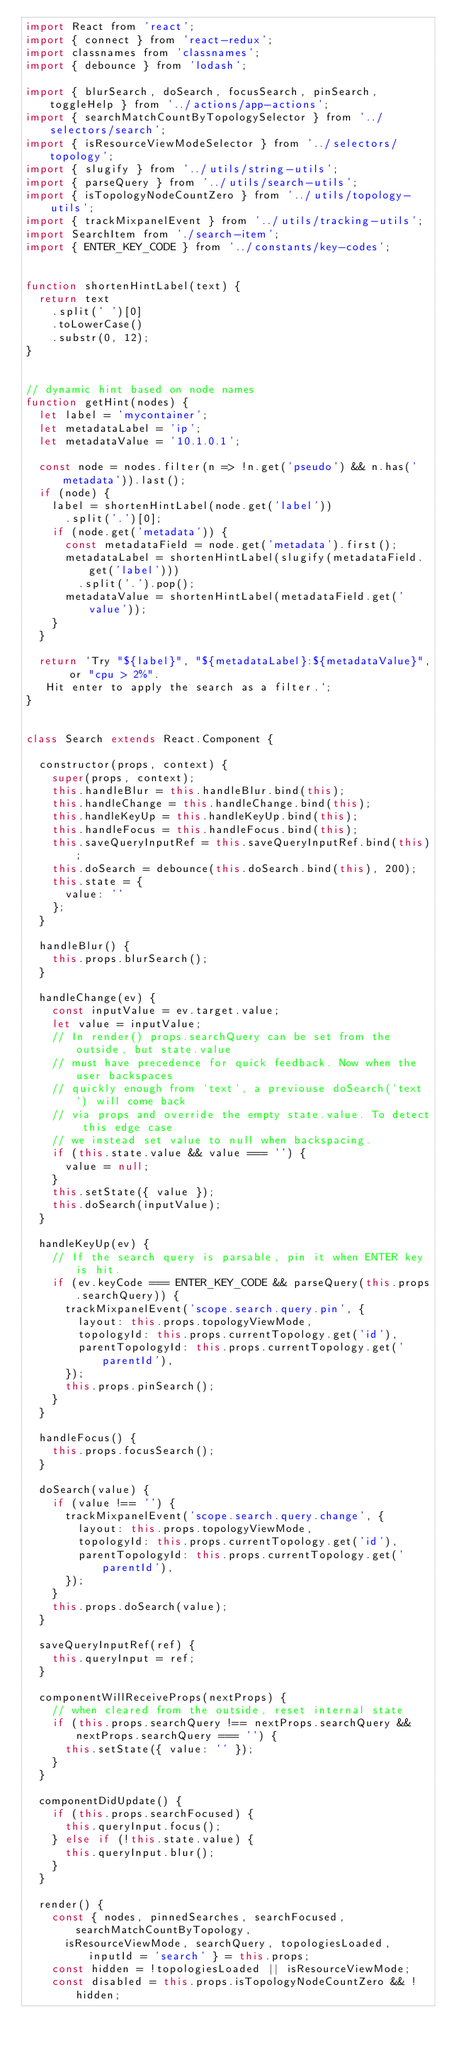Convert code to text. <code><loc_0><loc_0><loc_500><loc_500><_JavaScript_>import React from 'react';
import { connect } from 'react-redux';
import classnames from 'classnames';
import { debounce } from 'lodash';

import { blurSearch, doSearch, focusSearch, pinSearch, toggleHelp } from '../actions/app-actions';
import { searchMatchCountByTopologySelector } from '../selectors/search';
import { isResourceViewModeSelector } from '../selectors/topology';
import { slugify } from '../utils/string-utils';
import { parseQuery } from '../utils/search-utils';
import { isTopologyNodeCountZero } from '../utils/topology-utils';
import { trackMixpanelEvent } from '../utils/tracking-utils';
import SearchItem from './search-item';
import { ENTER_KEY_CODE } from '../constants/key-codes';


function shortenHintLabel(text) {
  return text
    .split(' ')[0]
    .toLowerCase()
    .substr(0, 12);
}


// dynamic hint based on node names
function getHint(nodes) {
  let label = 'mycontainer';
  let metadataLabel = 'ip';
  let metadataValue = '10.1.0.1';

  const node = nodes.filter(n => !n.get('pseudo') && n.has('metadata')).last();
  if (node) {
    label = shortenHintLabel(node.get('label'))
      .split('.')[0];
    if (node.get('metadata')) {
      const metadataField = node.get('metadata').first();
      metadataLabel = shortenHintLabel(slugify(metadataField.get('label')))
        .split('.').pop();
      metadataValue = shortenHintLabel(metadataField.get('value'));
    }
  }

  return `Try "${label}", "${metadataLabel}:${metadataValue}", or "cpu > 2%".
   Hit enter to apply the search as a filter.`;
}


class Search extends React.Component {

  constructor(props, context) {
    super(props, context);
    this.handleBlur = this.handleBlur.bind(this);
    this.handleChange = this.handleChange.bind(this);
    this.handleKeyUp = this.handleKeyUp.bind(this);
    this.handleFocus = this.handleFocus.bind(this);
    this.saveQueryInputRef = this.saveQueryInputRef.bind(this);
    this.doSearch = debounce(this.doSearch.bind(this), 200);
    this.state = {
      value: ''
    };
  }

  handleBlur() {
    this.props.blurSearch();
  }

  handleChange(ev) {
    const inputValue = ev.target.value;
    let value = inputValue;
    // In render() props.searchQuery can be set from the outside, but state.value
    // must have precedence for quick feedback. Now when the user backspaces
    // quickly enough from `text`, a previouse doSearch(`text`) will come back
    // via props and override the empty state.value. To detect this edge case
    // we instead set value to null when backspacing.
    if (this.state.value && value === '') {
      value = null;
    }
    this.setState({ value });
    this.doSearch(inputValue);
  }

  handleKeyUp(ev) {
    // If the search query is parsable, pin it when ENTER key is hit.
    if (ev.keyCode === ENTER_KEY_CODE && parseQuery(this.props.searchQuery)) {
      trackMixpanelEvent('scope.search.query.pin', {
        layout: this.props.topologyViewMode,
        topologyId: this.props.currentTopology.get('id'),
        parentTopologyId: this.props.currentTopology.get('parentId'),
      });
      this.props.pinSearch();
    }
  }

  handleFocus() {
    this.props.focusSearch();
  }

  doSearch(value) {
    if (value !== '') {
      trackMixpanelEvent('scope.search.query.change', {
        layout: this.props.topologyViewMode,
        topologyId: this.props.currentTopology.get('id'),
        parentTopologyId: this.props.currentTopology.get('parentId'),
      });
    }
    this.props.doSearch(value);
  }

  saveQueryInputRef(ref) {
    this.queryInput = ref;
  }

  componentWillReceiveProps(nextProps) {
    // when cleared from the outside, reset internal state
    if (this.props.searchQuery !== nextProps.searchQuery && nextProps.searchQuery === '') {
      this.setState({ value: '' });
    }
  }

  componentDidUpdate() {
    if (this.props.searchFocused) {
      this.queryInput.focus();
    } else if (!this.state.value) {
      this.queryInput.blur();
    }
  }

  render() {
    const { nodes, pinnedSearches, searchFocused, searchMatchCountByTopology,
      isResourceViewMode, searchQuery, topologiesLoaded, inputId = 'search' } = this.props;
    const hidden = !topologiesLoaded || isResourceViewMode;
    const disabled = this.props.isTopologyNodeCountZero && !hidden;</code> 